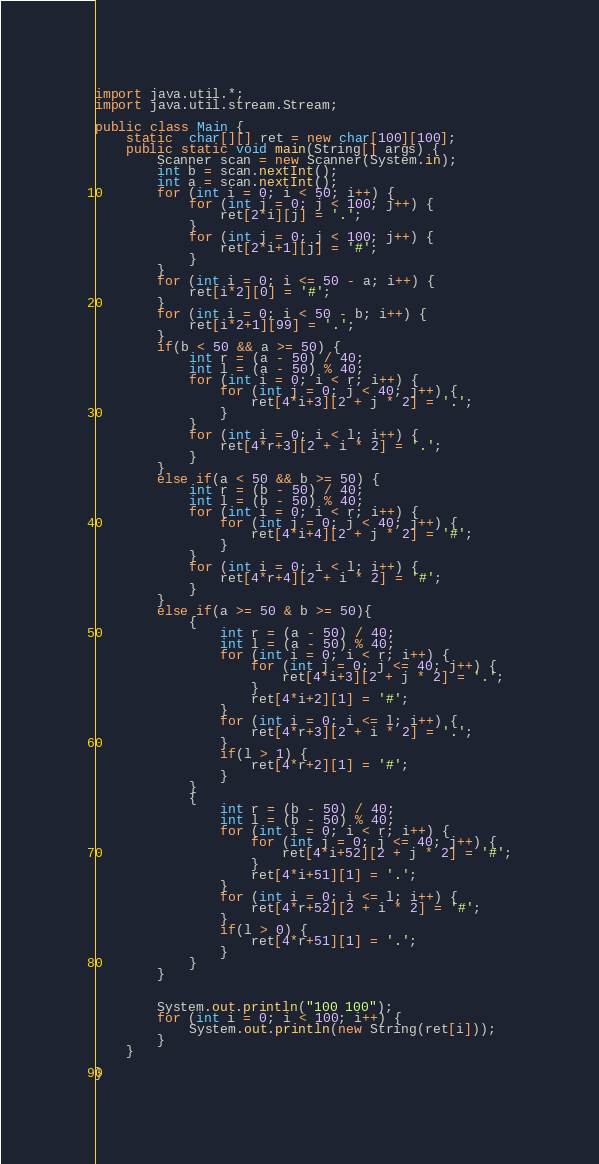<code> <loc_0><loc_0><loc_500><loc_500><_Java_>import java.util.*;
import java.util.stream.Stream;

public class Main {
    static  char[][] ret = new char[100][100];
    public static void main(String[] args) {
        Scanner scan = new Scanner(System.in);
        int b = scan.nextInt();
        int a = scan.nextInt();
        for (int i = 0; i < 50; i++) {
            for (int j = 0; j < 100; j++) {
                ret[2*i][j] = '.';
            }
            for (int j = 0; j < 100; j++) {
                ret[2*i+1][j] = '#';
            }
        }
        for (int i = 0; i <= 50 - a; i++) {
            ret[i*2][0] = '#';
        }
        for (int i = 0; i < 50 - b; i++) {
            ret[i*2+1][99] = '.';
        }
        if(b < 50 && a >= 50) {
            int r = (a - 50) / 40;
            int l = (a - 50) % 40;
            for (int i = 0; i < r; i++) {
                for (int j = 0; j < 40; j++) {
                    ret[4*i+3][2 + j * 2] = '.';
                }
            }
            for (int i = 0; i < l; i++) {
                ret[4*r+3][2 + i * 2] = '.';
            }
        }
        else if(a < 50 && b >= 50) {
            int r = (b - 50) / 40;
            int l = (b - 50) % 40;
            for (int i = 0; i < r; i++) {
                for (int j = 0; j < 40; j++) {
                    ret[4*i+4][2 + j * 2] = '#';
                }
            }
            for (int i = 0; i < l; i++) {
                ret[4*r+4][2 + i * 2] = '#';
            }
        }
        else if(a >= 50 & b >= 50){
            {
                int r = (a - 50) / 40;
                int l = (a - 50) % 40;
                for (int i = 0; i < r; i++) {
                    for (int j = 0; j <= 40; j++) {
                        ret[4*i+3][2 + j * 2] = '.';
                    }
                    ret[4*i+2][1] = '#';
                }
                for (int i = 0; i <= l; i++) {
                    ret[4*r+3][2 + i * 2] = '.';
                }
                if(l > 1) {
                    ret[4*r+2][1] = '#';
                }
            }
            {
                int r = (b - 50) / 40;
                int l = (b - 50) % 40;
                for (int i = 0; i < r; i++) {
                    for (int j = 0; j <= 40; j++) {
                        ret[4*i+52][2 + j * 2] = '#';
                    }
                    ret[4*i+51][1] = '.';
                }
                for (int i = 0; i <= l; i++) {
                    ret[4*r+52][2 + i * 2] = '#';
                }
                if(l > 0) {
                    ret[4*r+51][1] = '.';
                }
            }
        }


        System.out.println("100 100");
        for (int i = 0; i < 100; i++) {
            System.out.println(new String(ret[i]));
        }
    }

}
</code> 